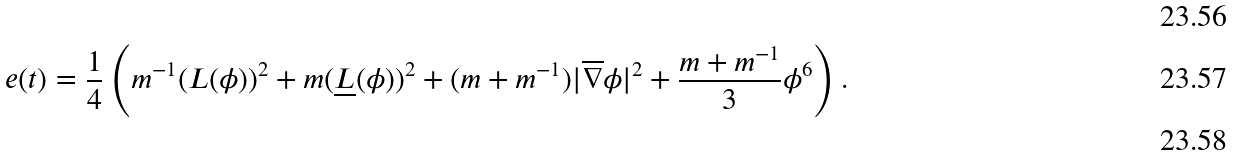<formula> <loc_0><loc_0><loc_500><loc_500>\\ e ( t ) = \frac { 1 } { 4 } \left ( m ^ { - 1 } ( L ( \phi ) ) ^ { 2 } + m ( \underline { L } ( \phi ) ) ^ { 2 } + ( m + m ^ { - 1 } ) | \overline { \nabla } \phi | ^ { 2 } + \frac { m + m ^ { - 1 } } { 3 } \phi ^ { 6 } \right ) . \\</formula> 